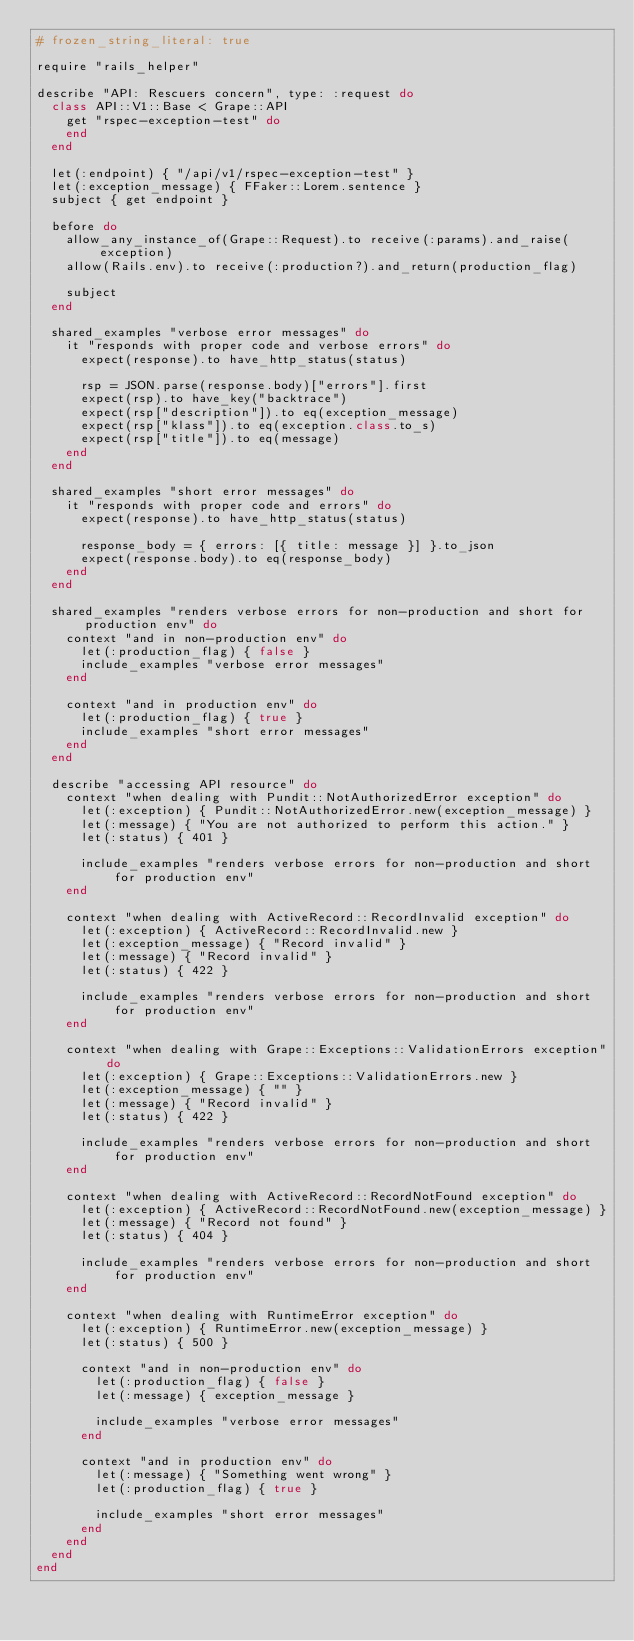Convert code to text. <code><loc_0><loc_0><loc_500><loc_500><_Ruby_># frozen_string_literal: true

require "rails_helper"

describe "API: Rescuers concern", type: :request do
  class API::V1::Base < Grape::API
    get "rspec-exception-test" do
    end
  end

  let(:endpoint) { "/api/v1/rspec-exception-test" }
  let(:exception_message) { FFaker::Lorem.sentence }
  subject { get endpoint }

  before do
    allow_any_instance_of(Grape::Request).to receive(:params).and_raise(exception)
    allow(Rails.env).to receive(:production?).and_return(production_flag)

    subject
  end

  shared_examples "verbose error messages" do
    it "responds with proper code and verbose errors" do
      expect(response).to have_http_status(status)

      rsp = JSON.parse(response.body)["errors"].first
      expect(rsp).to have_key("backtrace")
      expect(rsp["description"]).to eq(exception_message)
      expect(rsp["klass"]).to eq(exception.class.to_s)
      expect(rsp["title"]).to eq(message)
    end
  end

  shared_examples "short error messages" do
    it "responds with proper code and errors" do
      expect(response).to have_http_status(status)

      response_body = { errors: [{ title: message }] }.to_json
      expect(response.body).to eq(response_body)
    end
  end

  shared_examples "renders verbose errors for non-production and short for production env" do
    context "and in non-production env" do
      let(:production_flag) { false }
      include_examples "verbose error messages"
    end

    context "and in production env" do
      let(:production_flag) { true }
      include_examples "short error messages"
    end
  end

  describe "accessing API resource" do
    context "when dealing with Pundit::NotAuthorizedError exception" do
      let(:exception) { Pundit::NotAuthorizedError.new(exception_message) }
      let(:message) { "You are not authorized to perform this action." }
      let(:status) { 401 }

      include_examples "renders verbose errors for non-production and short for production env"
    end

    context "when dealing with ActiveRecord::RecordInvalid exception" do
      let(:exception) { ActiveRecord::RecordInvalid.new }
      let(:exception_message) { "Record invalid" }
      let(:message) { "Record invalid" }
      let(:status) { 422 }

      include_examples "renders verbose errors for non-production and short for production env"
    end

    context "when dealing with Grape::Exceptions::ValidationErrors exception" do
      let(:exception) { Grape::Exceptions::ValidationErrors.new }
      let(:exception_message) { "" }
      let(:message) { "Record invalid" }
      let(:status) { 422 }

      include_examples "renders verbose errors for non-production and short for production env"
    end

    context "when dealing with ActiveRecord::RecordNotFound exception" do
      let(:exception) { ActiveRecord::RecordNotFound.new(exception_message) }
      let(:message) { "Record not found" }
      let(:status) { 404 }

      include_examples "renders verbose errors for non-production and short for production env"
    end

    context "when dealing with RuntimeError exception" do
      let(:exception) { RuntimeError.new(exception_message) }
      let(:status) { 500 }

      context "and in non-production env" do
        let(:production_flag) { false }
        let(:message) { exception_message }

        include_examples "verbose error messages"
      end

      context "and in production env" do
        let(:message) { "Something went wrong" }
        let(:production_flag) { true }

        include_examples "short error messages"
      end
    end
  end
end
</code> 